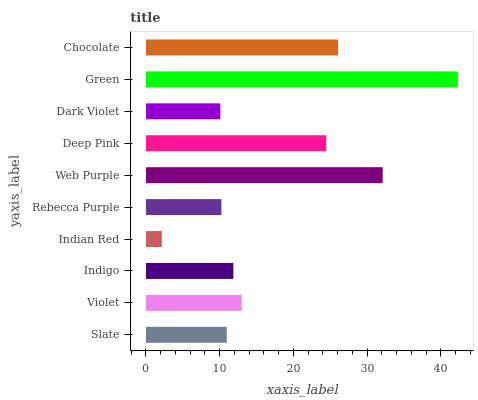Is Indian Red the minimum?
Answer yes or no. Yes. Is Green the maximum?
Answer yes or no. Yes. Is Violet the minimum?
Answer yes or no. No. Is Violet the maximum?
Answer yes or no. No. Is Violet greater than Slate?
Answer yes or no. Yes. Is Slate less than Violet?
Answer yes or no. Yes. Is Slate greater than Violet?
Answer yes or no. No. Is Violet less than Slate?
Answer yes or no. No. Is Violet the high median?
Answer yes or no. Yes. Is Indigo the low median?
Answer yes or no. Yes. Is Indigo the high median?
Answer yes or no. No. Is Deep Pink the low median?
Answer yes or no. No. 